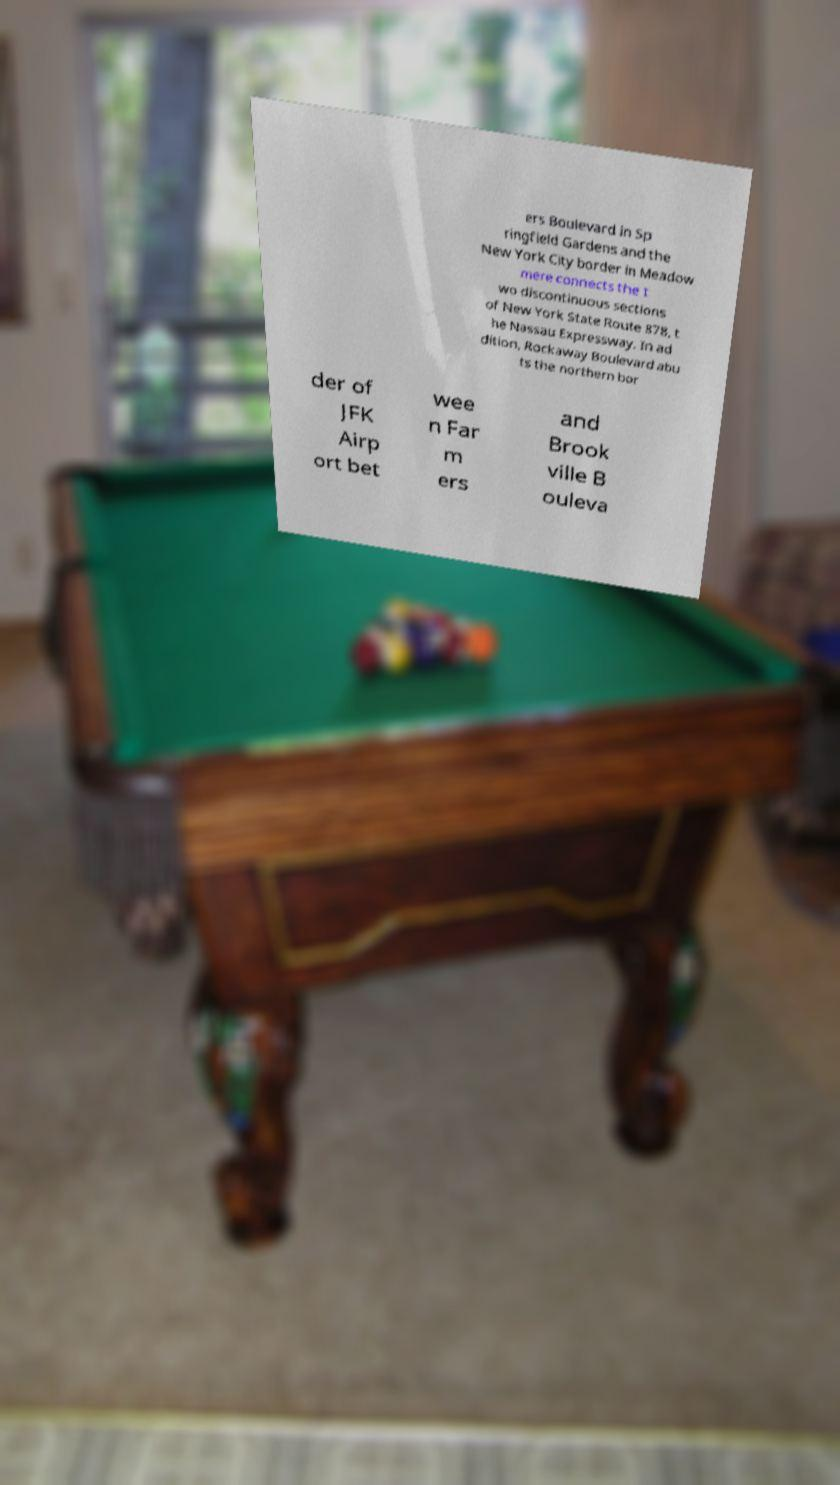Can you read and provide the text displayed in the image?This photo seems to have some interesting text. Can you extract and type it out for me? ers Boulevard in Sp ringfield Gardens and the New York City border in Meadow mere connects the t wo discontinuous sections of New York State Route 878, t he Nassau Expressway. In ad dition, Rockaway Boulevard abu ts the northern bor der of JFK Airp ort bet wee n Far m ers and Brook ville B ouleva 